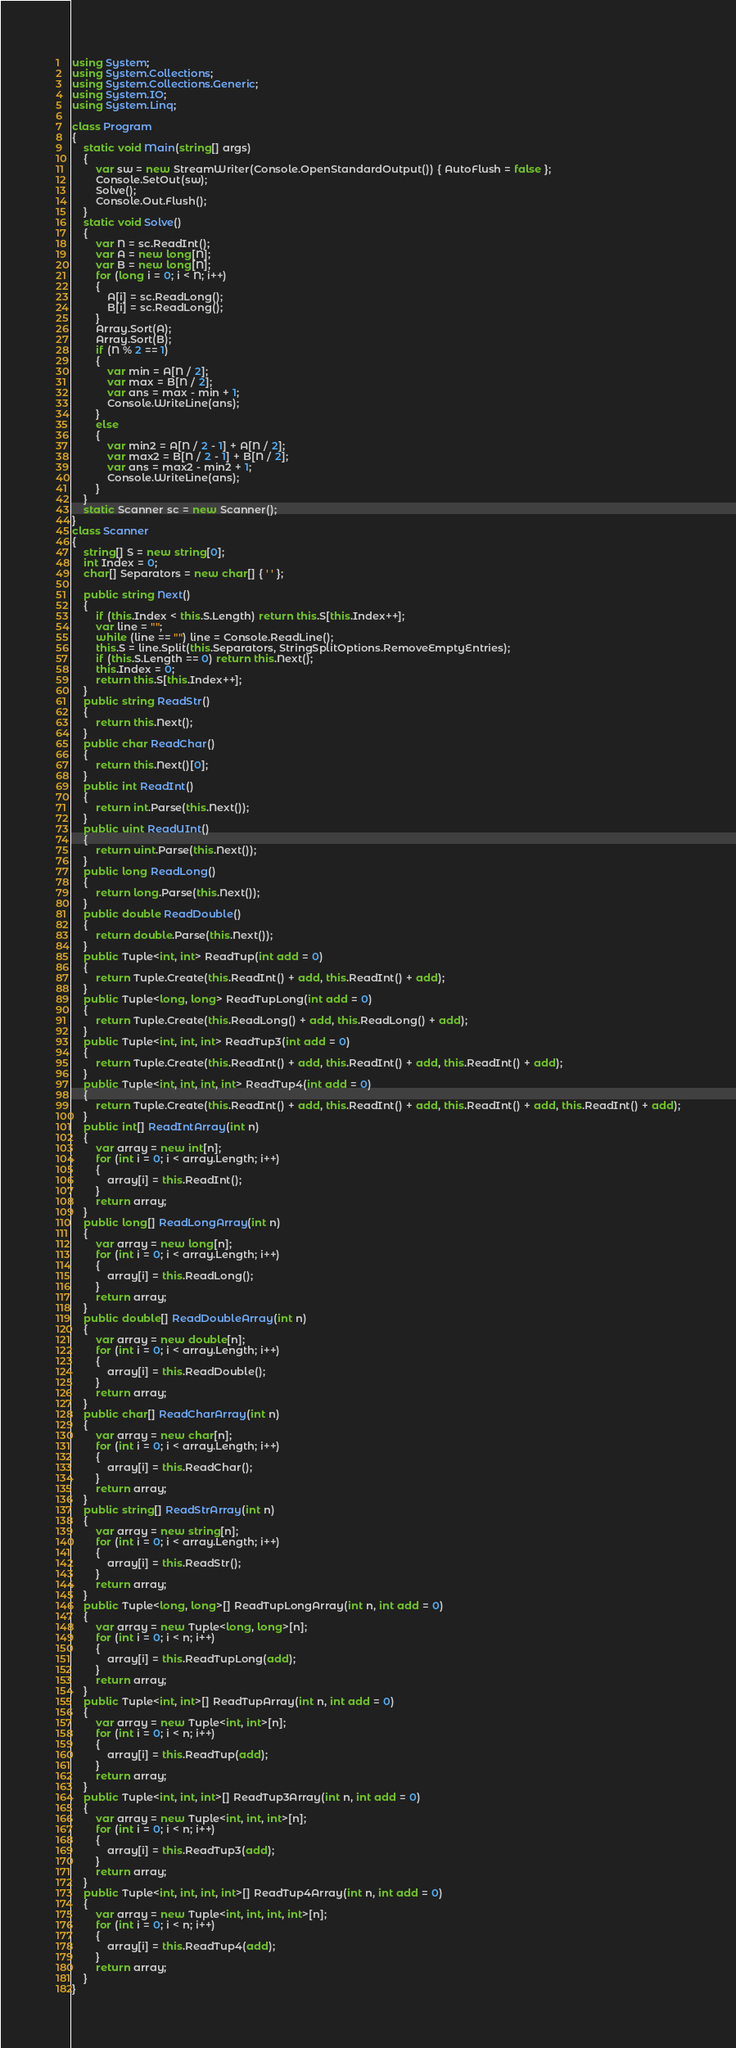Convert code to text. <code><loc_0><loc_0><loc_500><loc_500><_C#_>using System;
using System.Collections;
using System.Collections.Generic;
using System.IO;
using System.Linq;

class Program
{
    static void Main(string[] args)
    {
        var sw = new StreamWriter(Console.OpenStandardOutput()) { AutoFlush = false };
        Console.SetOut(sw);
        Solve();
        Console.Out.Flush();
    }
    static void Solve()
    {
        var N = sc.ReadInt();
        var A = new long[N];
        var B = new long[N];
        for (long i = 0; i < N; i++)
        {
            A[i] = sc.ReadLong();
            B[i] = sc.ReadLong();
        }
        Array.Sort(A);
        Array.Sort(B);
        if (N % 2 == 1)
        {
            var min = A[N / 2];
            var max = B[N / 2];
            var ans = max - min + 1;
            Console.WriteLine(ans);
        }
        else
        {
            var min2 = A[N / 2 - 1] + A[N / 2];
            var max2 = B[N / 2 - 1] + B[N / 2];
            var ans = max2 - min2 + 1;
            Console.WriteLine(ans);
        }
    }
    static Scanner sc = new Scanner();
}
class Scanner
{
    string[] S = new string[0];
    int Index = 0;
    char[] Separators = new char[] { ' ' };

    public string Next()
    {
        if (this.Index < this.S.Length) return this.S[this.Index++];
        var line = "";
        while (line == "") line = Console.ReadLine();
        this.S = line.Split(this.Separators, StringSplitOptions.RemoveEmptyEntries);
        if (this.S.Length == 0) return this.Next();
        this.Index = 0;
        return this.S[this.Index++];
    }
    public string ReadStr()
    {
        return this.Next();
    }
    public char ReadChar()
    {
        return this.Next()[0];
    }
    public int ReadInt()
    {
        return int.Parse(this.Next());
    }
    public uint ReadUInt()
    {
        return uint.Parse(this.Next());
    }
    public long ReadLong()
    {
        return long.Parse(this.Next());
    }
    public double ReadDouble()
    {
        return double.Parse(this.Next());
    }
    public Tuple<int, int> ReadTup(int add = 0)
    {
        return Tuple.Create(this.ReadInt() + add, this.ReadInt() + add);
    }
    public Tuple<long, long> ReadTupLong(int add = 0)
    {
        return Tuple.Create(this.ReadLong() + add, this.ReadLong() + add);
    }
    public Tuple<int, int, int> ReadTup3(int add = 0)
    {
        return Tuple.Create(this.ReadInt() + add, this.ReadInt() + add, this.ReadInt() + add);
    }
    public Tuple<int, int, int, int> ReadTup4(int add = 0)
    {
        return Tuple.Create(this.ReadInt() + add, this.ReadInt() + add, this.ReadInt() + add, this.ReadInt() + add);
    }
    public int[] ReadIntArray(int n)
    {
        var array = new int[n];
        for (int i = 0; i < array.Length; i++)
        {
            array[i] = this.ReadInt();
        }
        return array;
    }
    public long[] ReadLongArray(int n)
    {
        var array = new long[n];
        for (int i = 0; i < array.Length; i++)
        {
            array[i] = this.ReadLong();
        }
        return array;
    }
    public double[] ReadDoubleArray(int n)
    {
        var array = new double[n];
        for (int i = 0; i < array.Length; i++)
        {
            array[i] = this.ReadDouble();
        }
        return array;
    }
    public char[] ReadCharArray(int n)
    {
        var array = new char[n];
        for (int i = 0; i < array.Length; i++)
        {
            array[i] = this.ReadChar();
        }
        return array;
    }
    public string[] ReadStrArray(int n)
    {
        var array = new string[n];
        for (int i = 0; i < array.Length; i++)
        {
            array[i] = this.ReadStr();
        }
        return array;
    }
    public Tuple<long, long>[] ReadTupLongArray(int n, int add = 0)
    {
        var array = new Tuple<long, long>[n];
        for (int i = 0; i < n; i++)
        {
            array[i] = this.ReadTupLong(add);
        }
        return array;
    }
    public Tuple<int, int>[] ReadTupArray(int n, int add = 0)
    {
        var array = new Tuple<int, int>[n];
        for (int i = 0; i < n; i++)
        {
            array[i] = this.ReadTup(add);
        }
        return array;
    }
    public Tuple<int, int, int>[] ReadTup3Array(int n, int add = 0)
    {
        var array = new Tuple<int, int, int>[n];
        for (int i = 0; i < n; i++)
        {
            array[i] = this.ReadTup3(add);
        }
        return array;
    }
    public Tuple<int, int, int, int>[] ReadTup4Array(int n, int add = 0)
    {
        var array = new Tuple<int, int, int, int>[n];
        for (int i = 0; i < n; i++)
        {
            array[i] = this.ReadTup4(add);
        }
        return array;
    }
}
</code> 